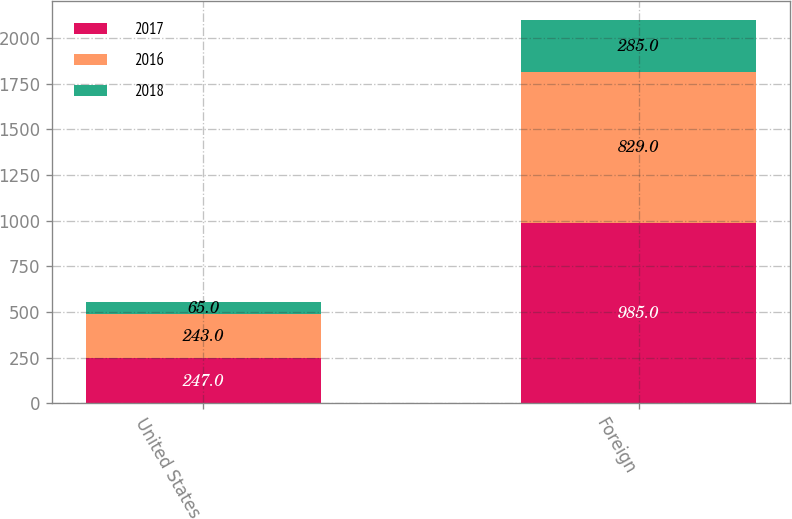Convert chart to OTSL. <chart><loc_0><loc_0><loc_500><loc_500><stacked_bar_chart><ecel><fcel>United States<fcel>Foreign<nl><fcel>2017<fcel>247<fcel>985<nl><fcel>2016<fcel>243<fcel>829<nl><fcel>2018<fcel>65<fcel>285<nl></chart> 